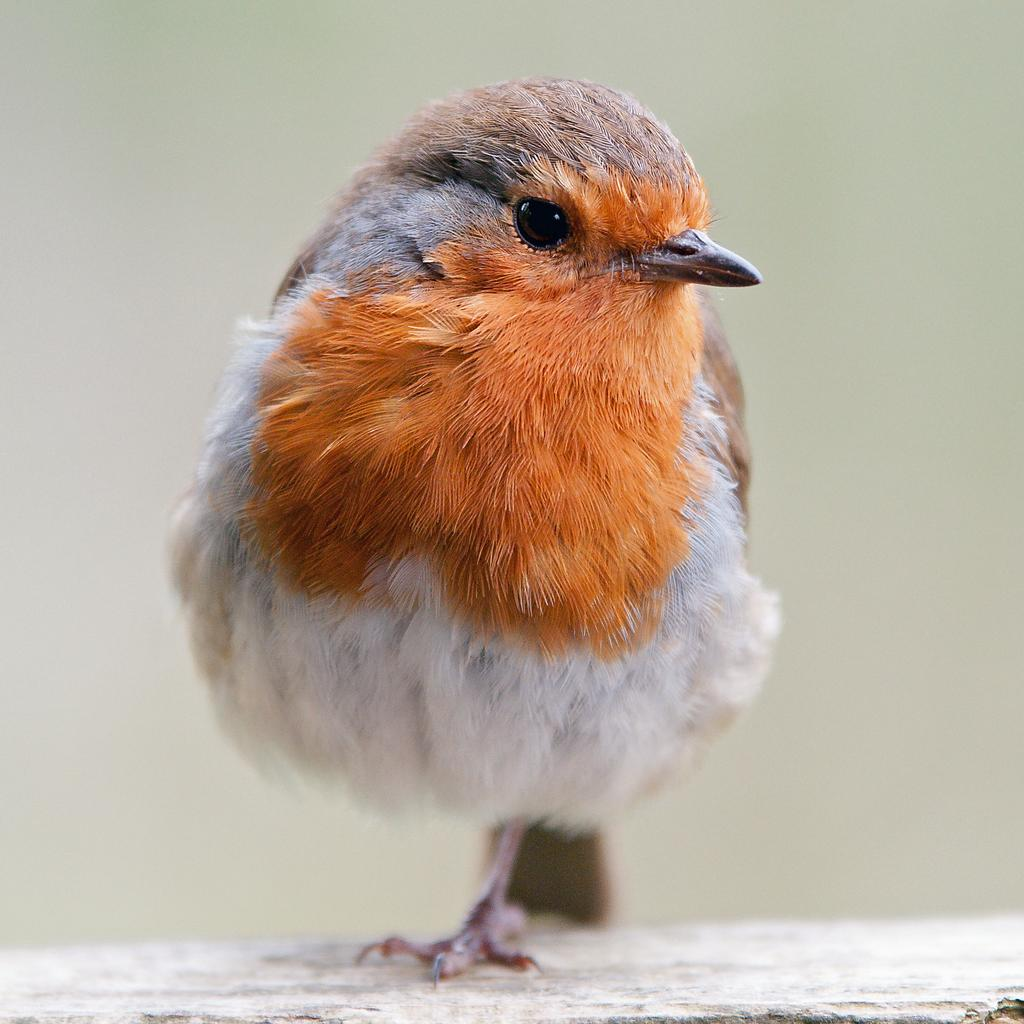What type of animal can be seen in the image? There is a bird in the image. Where is the bird located in the image? The bird is on a surface that resembles a wall. What color is the background of the image? The background of the image is white in color. What type of lumber is the bird using for its hobbies in the image? There is no lumber or hobbies mentioned or depicted in the image; it only features a bird on a surface that resembles a wall with a white background. 